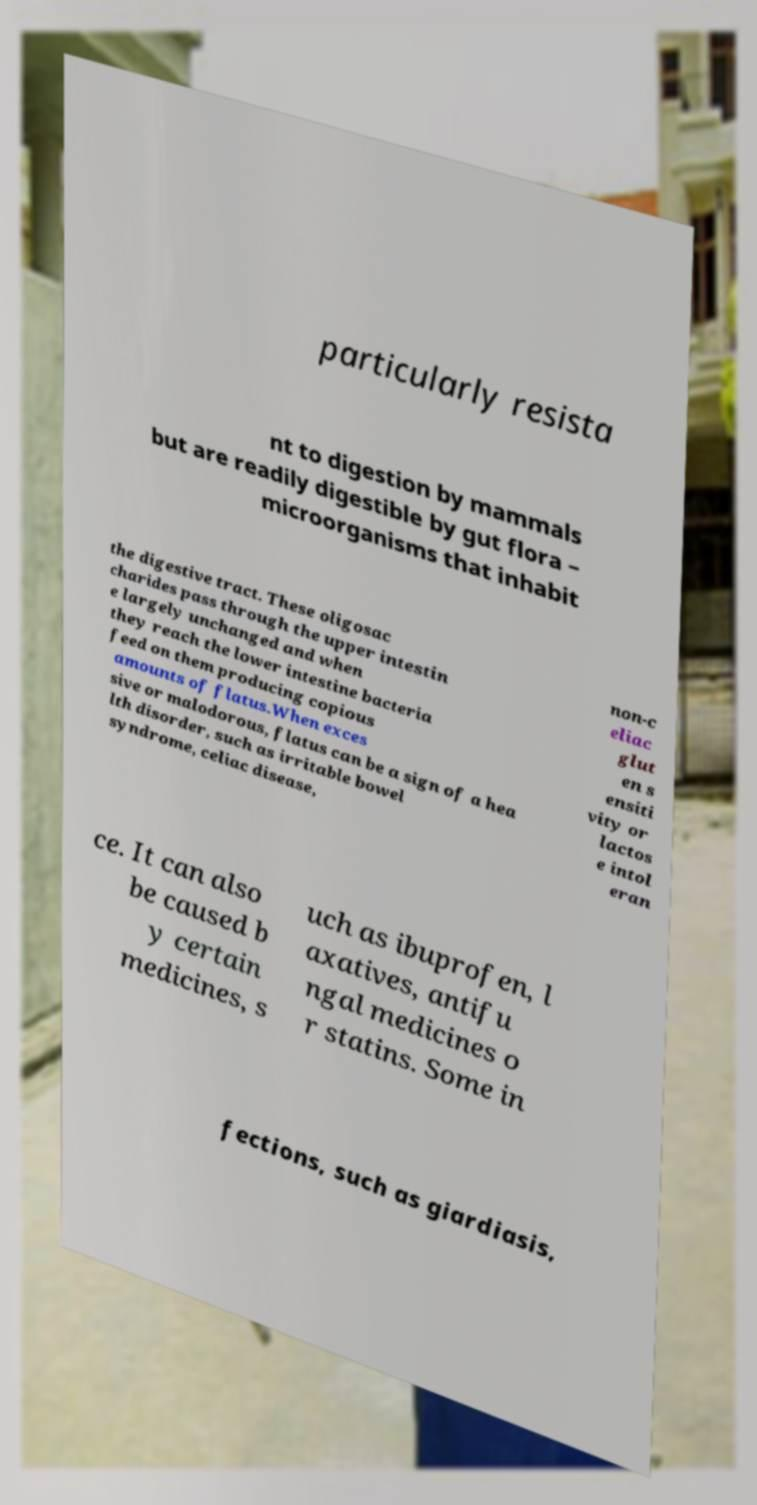Could you assist in decoding the text presented in this image and type it out clearly? particularly resista nt to digestion by mammals but are readily digestible by gut flora – microorganisms that inhabit the digestive tract. These oligosac charides pass through the upper intestin e largely unchanged and when they reach the lower intestine bacteria feed on them producing copious amounts of flatus.When exces sive or malodorous, flatus can be a sign of a hea lth disorder, such as irritable bowel syndrome, celiac disease, non-c eliac glut en s ensiti vity or lactos e intol eran ce. It can also be caused b y certain medicines, s uch as ibuprofen, l axatives, antifu ngal medicines o r statins. Some in fections, such as giardiasis, 